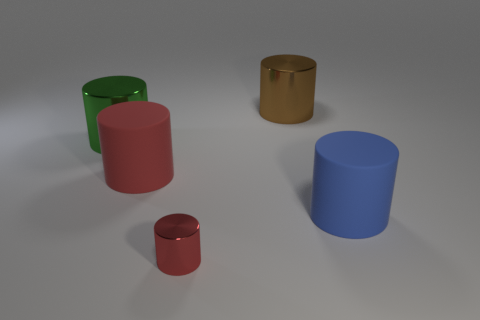What materials do the objects seem to be made of based on their appearance? Based on their sheen and texture, the objects appear to be composed of different materials. The green and the blue objects have a matte finish indicative of rubber, the pink object seems also to be made of rubber but has a slightly different texture, and the red object has a metallic gleam. Lastly, the golden object has a reflective surface that suggests it is made from a polished metal. 